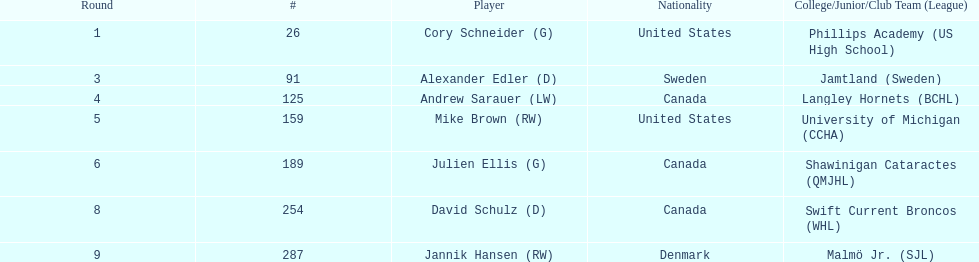Who is the canadian player that participated in the langley hornets team? Andrew Sarauer (LW). 